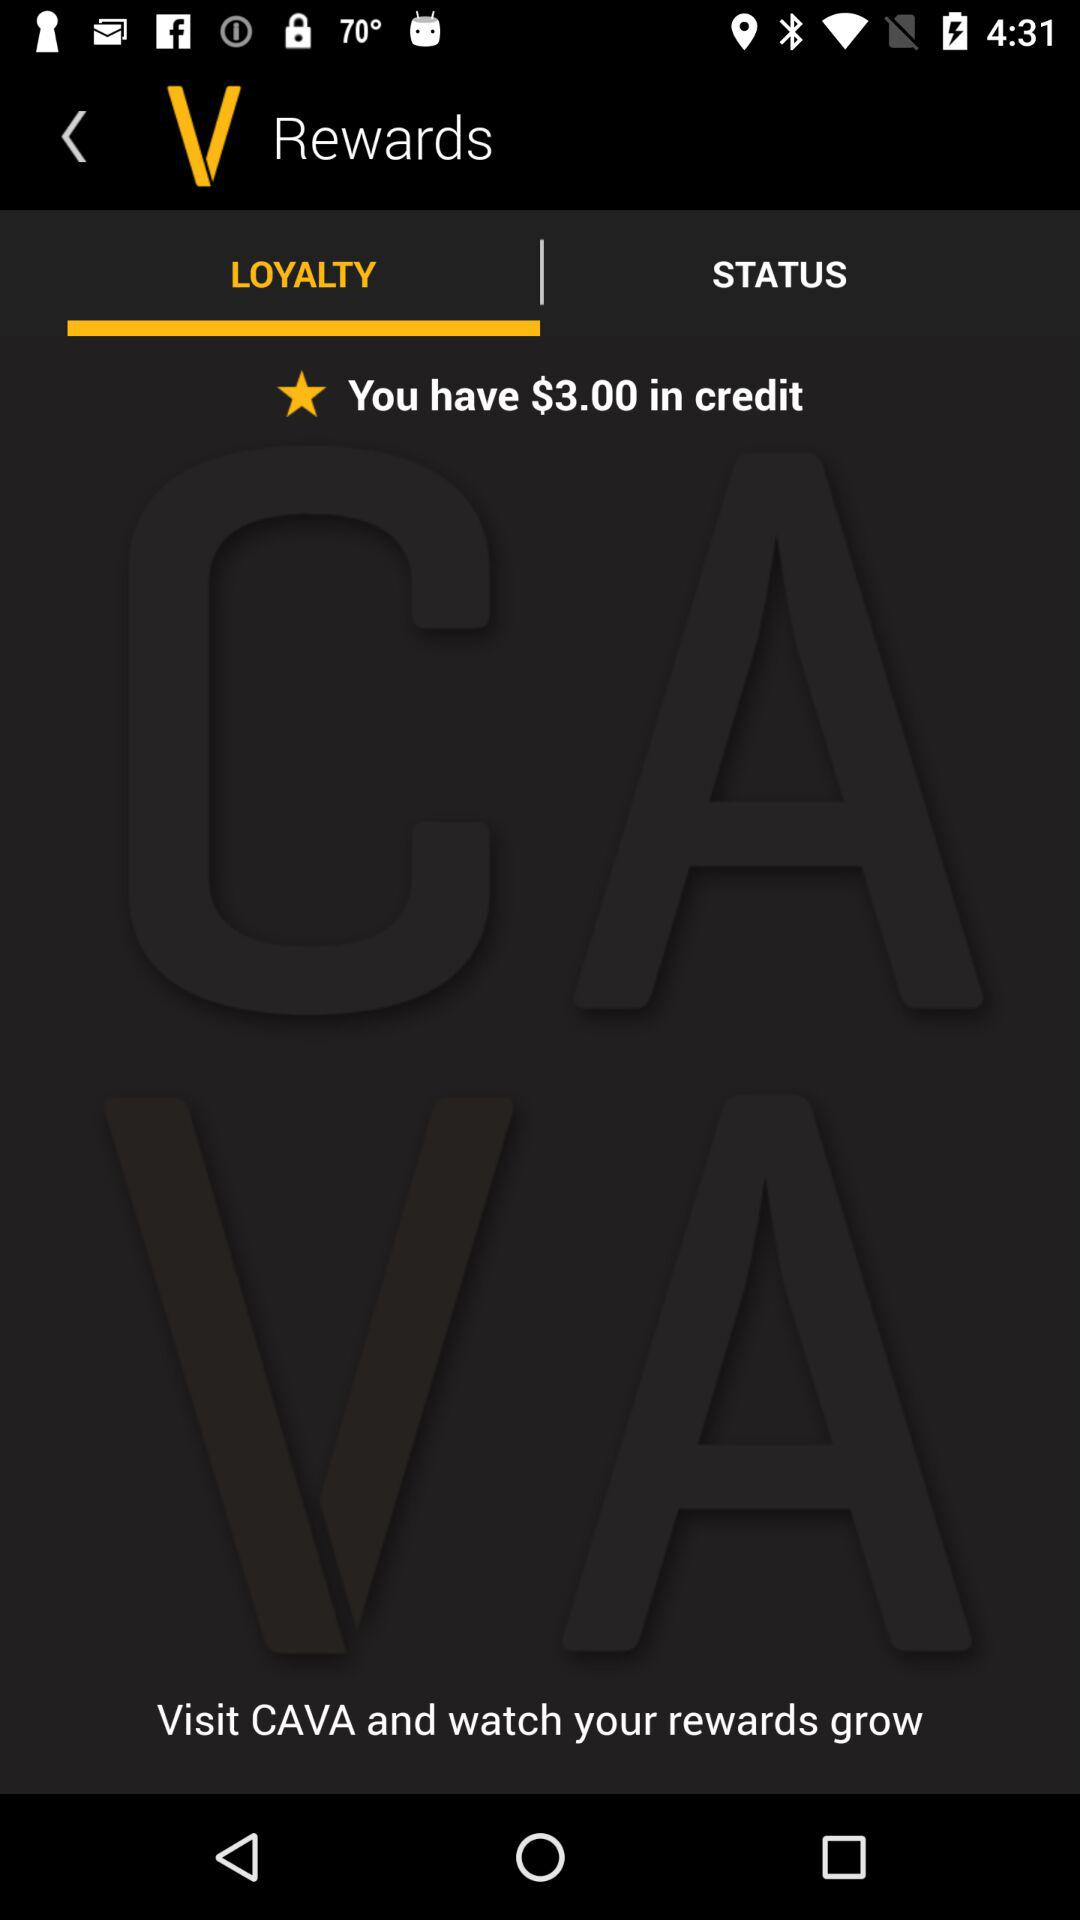Which tab is selected? The selected tab is "LOYALTY". 